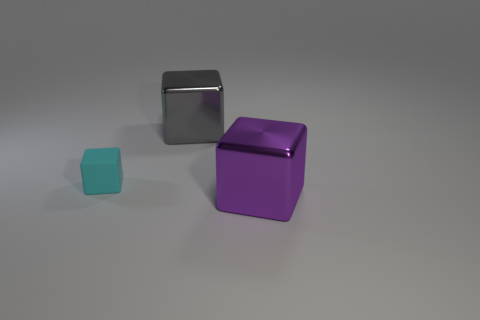Are there any other things that have the same material as the tiny cyan block?
Provide a succinct answer. No. Does the purple metal cube have the same size as the shiny object behind the cyan rubber cube?
Offer a very short reply. Yes. What number of other things are there of the same color as the tiny rubber thing?
Your response must be concise. 0. Is the number of large objects in front of the small cyan object greater than the number of tiny yellow things?
Your response must be concise. Yes. There is a big thing behind the matte cube that is left of the large metal object that is behind the small cyan object; what color is it?
Offer a very short reply. Gray. Are the big gray cube and the big purple object made of the same material?
Keep it short and to the point. Yes. Are there any metal objects that have the same size as the purple cube?
Make the answer very short. Yes. Is there a purple shiny object of the same shape as the big gray metallic object?
Your response must be concise. Yes. What number of large metallic things are there?
Provide a short and direct response. 2. What color is the other big block that is made of the same material as the big gray cube?
Give a very brief answer. Purple. 